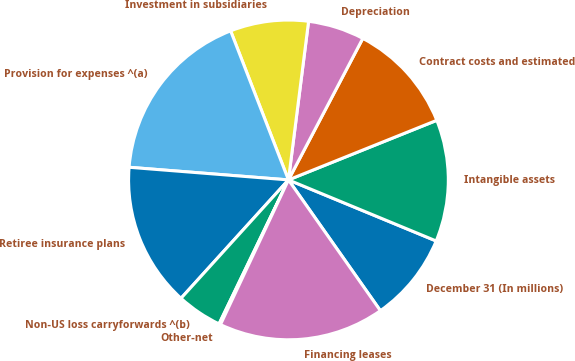<chart> <loc_0><loc_0><loc_500><loc_500><pie_chart><fcel>December 31 (In millions)<fcel>Intangible assets<fcel>Contract costs and estimated<fcel>Depreciation<fcel>Investment in subsidiaries<fcel>Provision for expenses ^(a)<fcel>Retiree insurance plans<fcel>Non-US loss carryforwards ^(b)<fcel>Other-net<fcel>Financing leases<nl><fcel>9.01%<fcel>12.32%<fcel>11.22%<fcel>5.69%<fcel>7.9%<fcel>17.85%<fcel>14.53%<fcel>4.58%<fcel>0.16%<fcel>16.74%<nl></chart> 